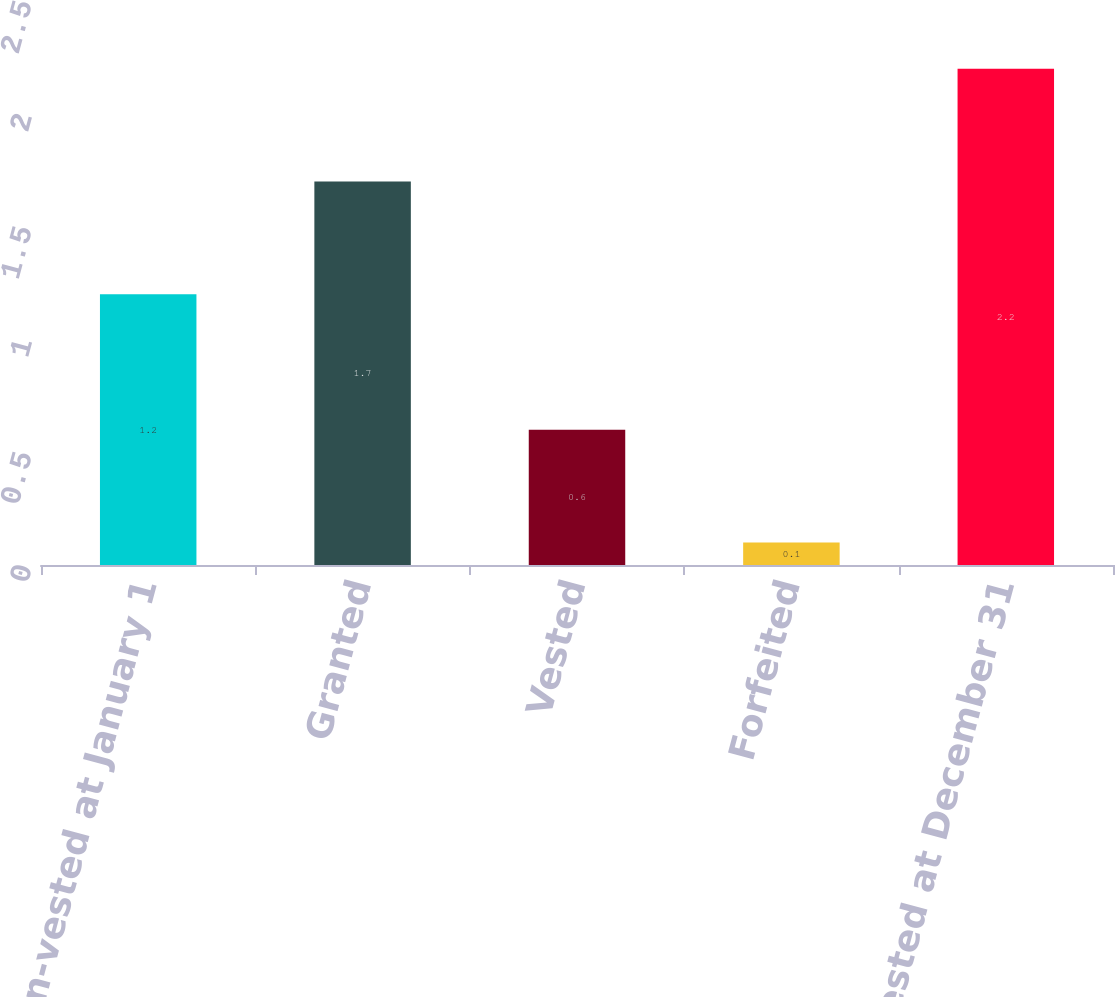<chart> <loc_0><loc_0><loc_500><loc_500><bar_chart><fcel>Non-vested at January 1<fcel>Granted<fcel>Vested<fcel>Forfeited<fcel>Non-vested at December 31<nl><fcel>1.2<fcel>1.7<fcel>0.6<fcel>0.1<fcel>2.2<nl></chart> 